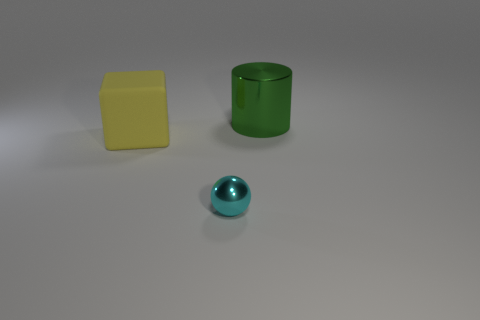Is there any other thing that is made of the same material as the large yellow cube?
Keep it short and to the point. No. Are there the same number of cylinders behind the green cylinder and small spheres that are behind the cyan thing?
Give a very brief answer. Yes. How many other objects are there of the same material as the tiny cyan object?
Make the answer very short. 1. What number of small things are cyan balls or matte blocks?
Make the answer very short. 1. Is the number of shiny things on the right side of the big green metal cylinder the same as the number of small gray cylinders?
Your response must be concise. Yes. Is there a small cyan metallic sphere to the right of the tiny shiny thing in front of the yellow block?
Keep it short and to the point. No. How many other things are there of the same color as the ball?
Provide a succinct answer. 0. What is the color of the tiny metal thing?
Ensure brevity in your answer.  Cyan. There is a object that is behind the small shiny sphere and on the right side of the large rubber thing; what size is it?
Offer a terse response. Large. How many objects are things in front of the green thing or large green shiny cubes?
Your answer should be very brief. 2. 